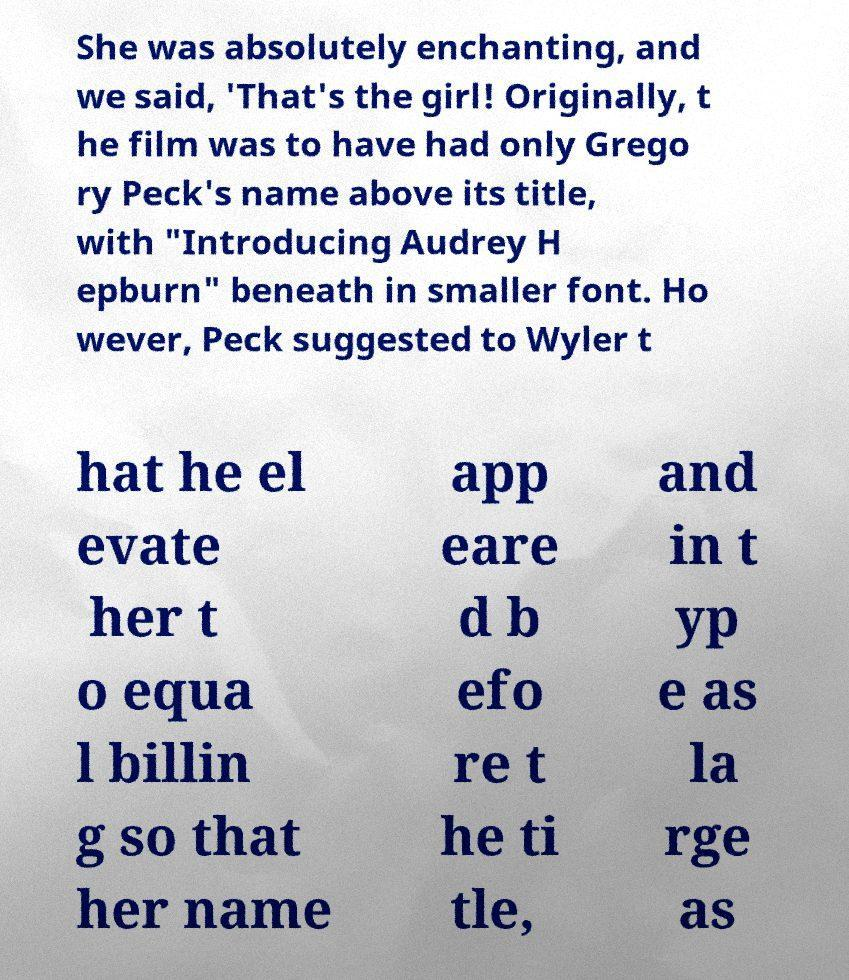Could you assist in decoding the text presented in this image and type it out clearly? She was absolutely enchanting, and we said, 'That's the girl! Originally, t he film was to have had only Grego ry Peck's name above its title, with "Introducing Audrey H epburn" beneath in smaller font. Ho wever, Peck suggested to Wyler t hat he el evate her t o equa l billin g so that her name app eare d b efo re t he ti tle, and in t yp e as la rge as 